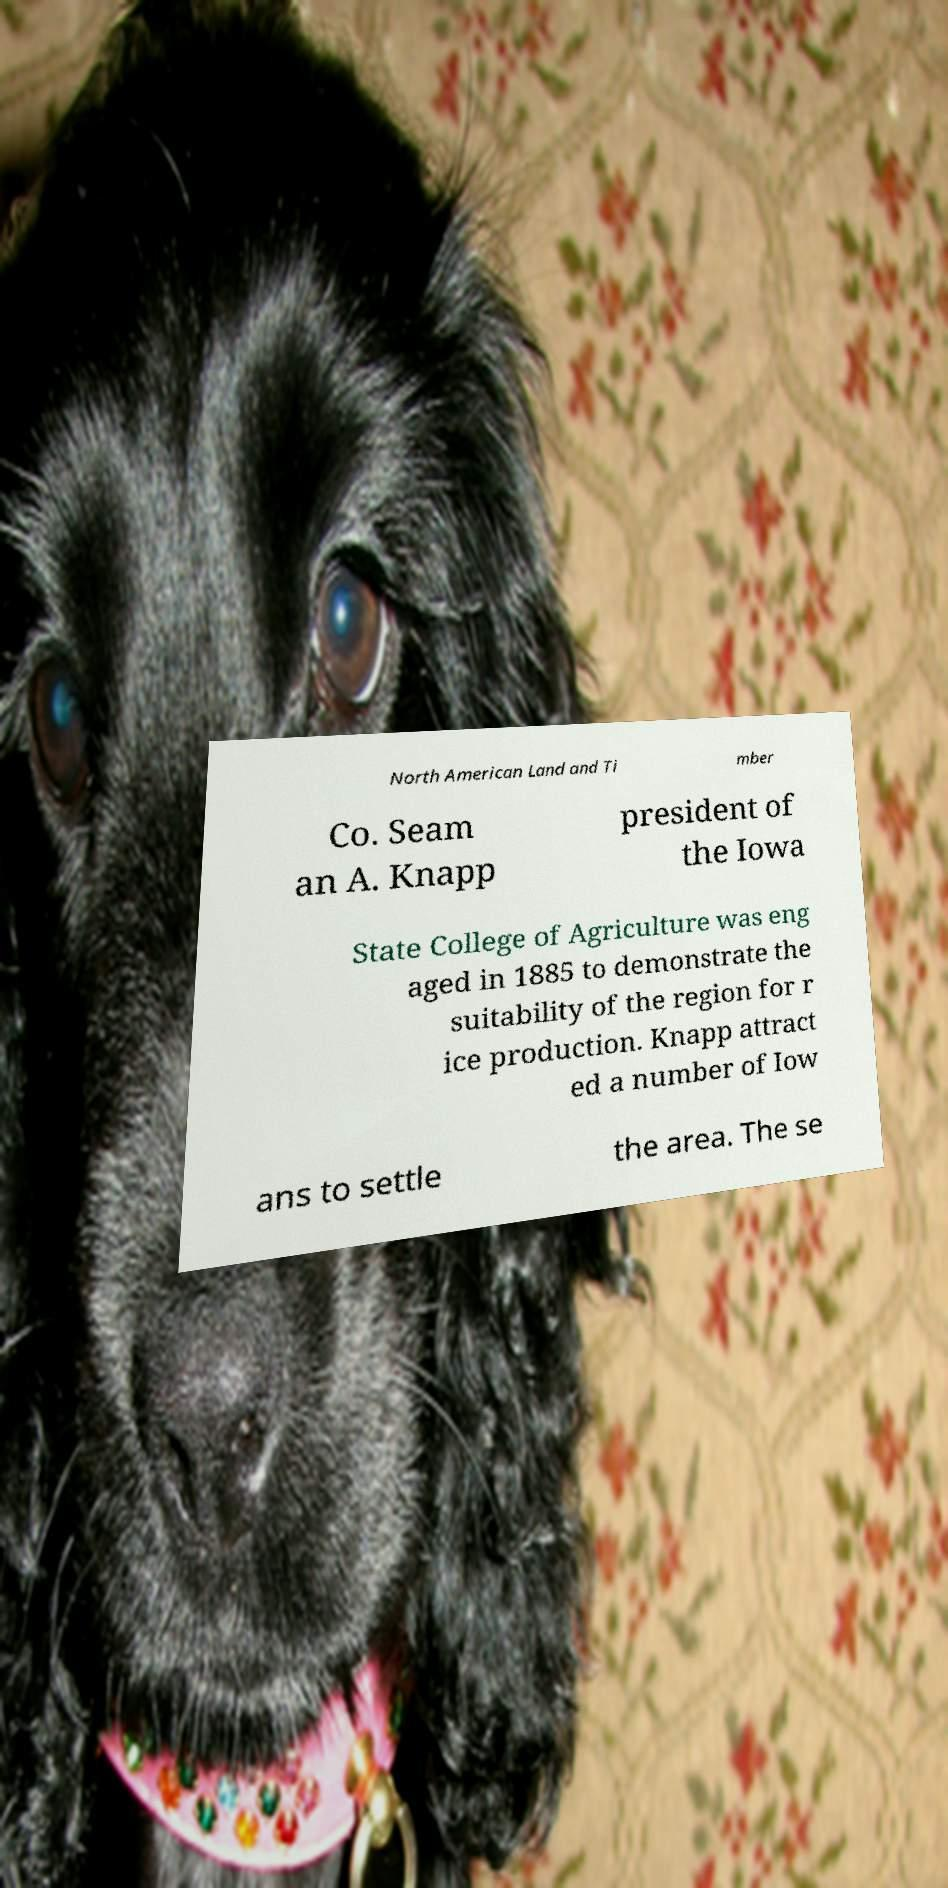Please identify and transcribe the text found in this image. North American Land and Ti mber Co. Seam an A. Knapp president of the Iowa State College of Agriculture was eng aged in 1885 to demonstrate the suitability of the region for r ice production. Knapp attract ed a number of Iow ans to settle the area. The se 